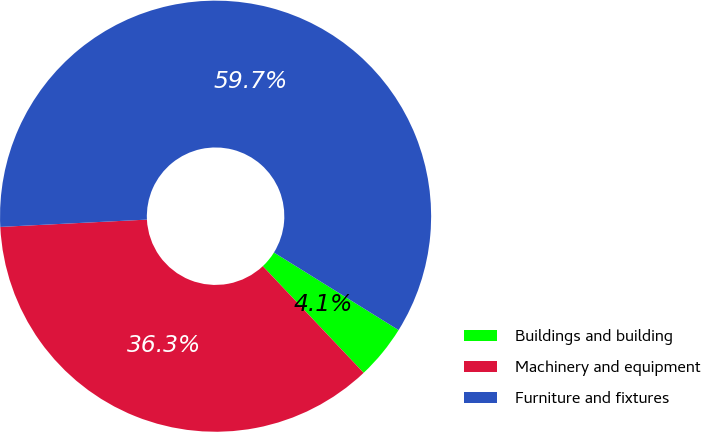Convert chart. <chart><loc_0><loc_0><loc_500><loc_500><pie_chart><fcel>Buildings and building<fcel>Machinery and equipment<fcel>Furniture and fixtures<nl><fcel>4.09%<fcel>36.26%<fcel>59.65%<nl></chart> 